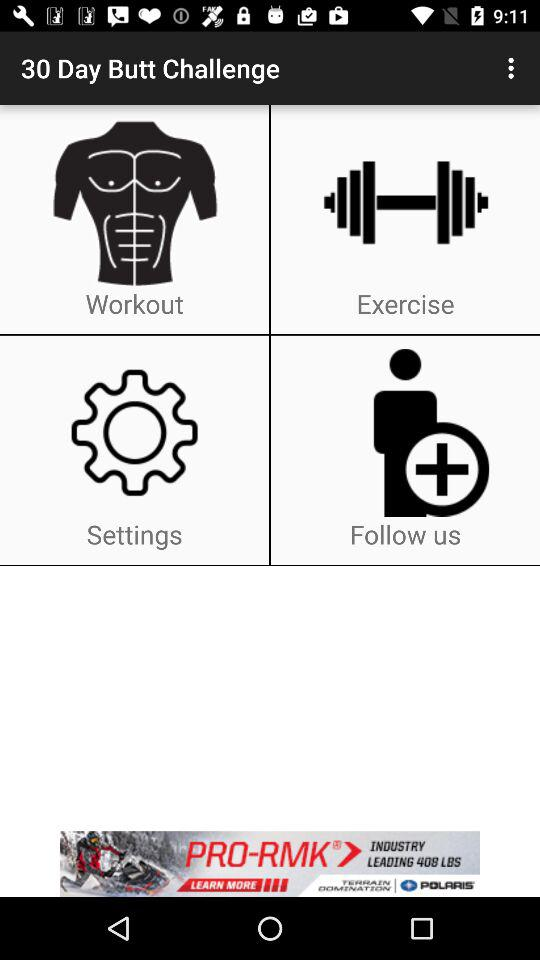What is the application name? The application name is "30 Day Butt Challenge". 